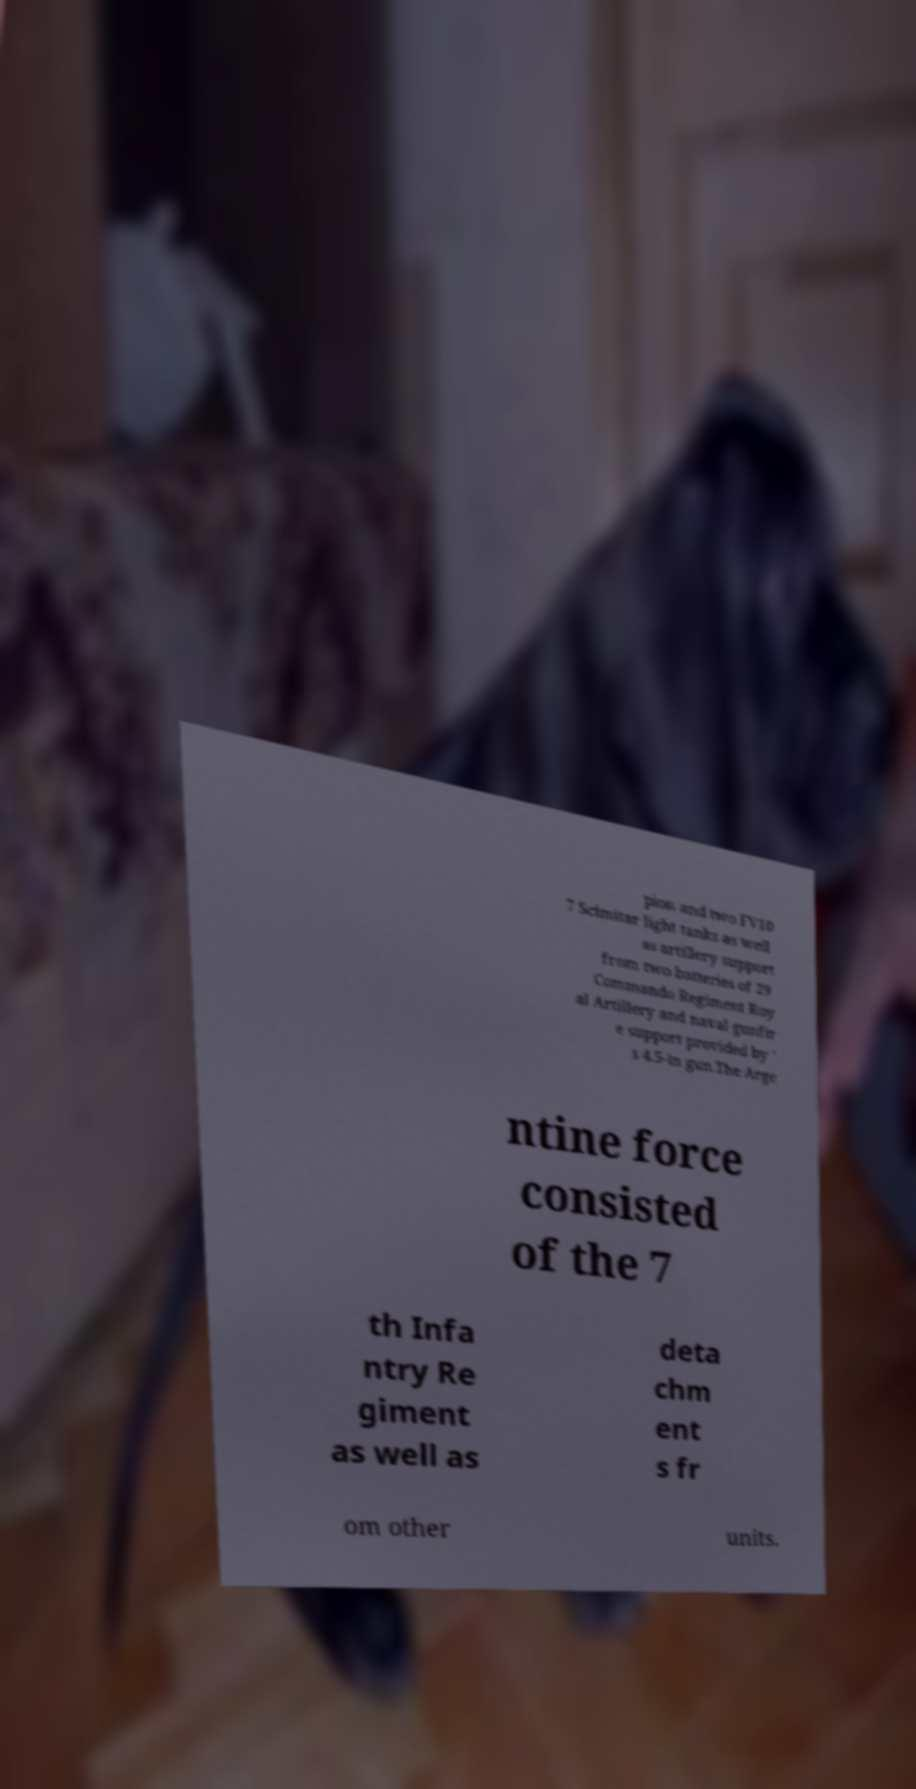Could you assist in decoding the text presented in this image and type it out clearly? pion and two FV10 7 Scimitar light tanks as well as artillery support from two batteries of 29 Commando Regiment Roy al Artillery and naval gunfir e support provided by ' s 4.5-in gun.The Arge ntine force consisted of the 7 th Infa ntry Re giment as well as deta chm ent s fr om other units. 